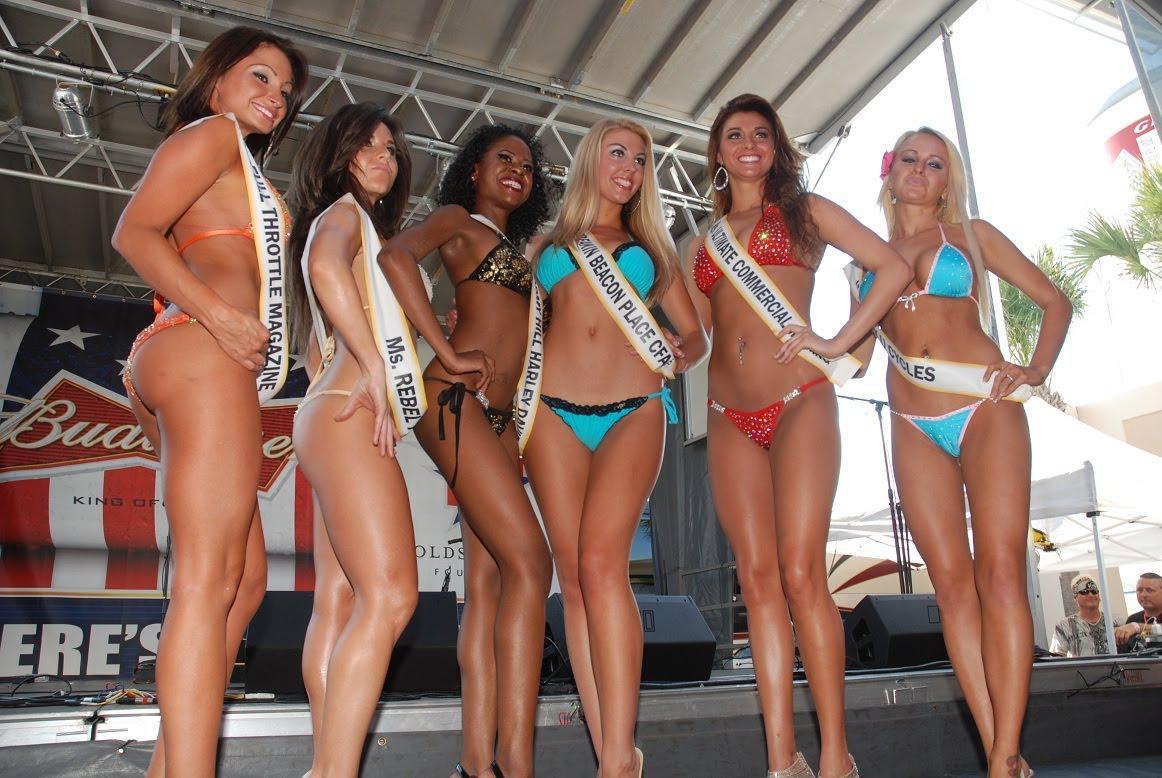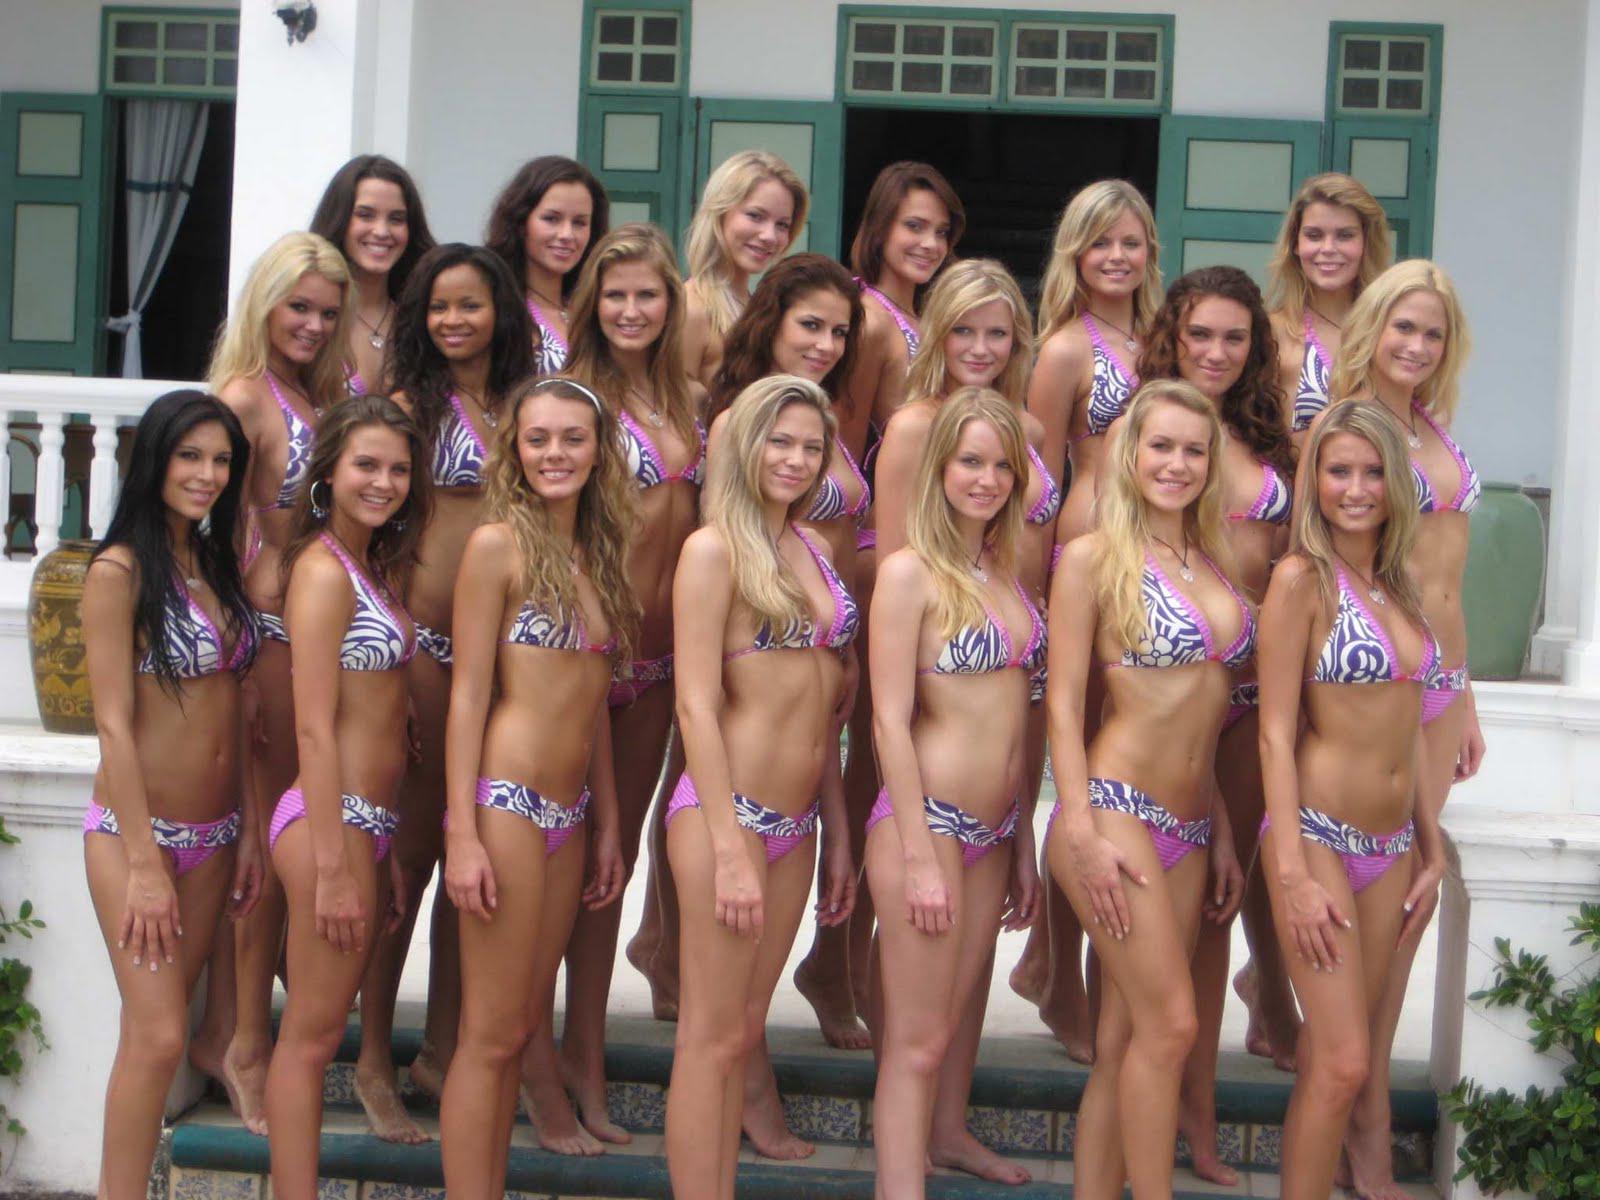The first image is the image on the left, the second image is the image on the right. For the images displayed, is the sentence "The women in the right image are wearing matching bikinis." factually correct? Answer yes or no. Yes. The first image is the image on the left, the second image is the image on the right. Examine the images to the left and right. Is the description "In at least one image there is at least six bodybuilders in bikinis." accurate? Answer yes or no. Yes. 